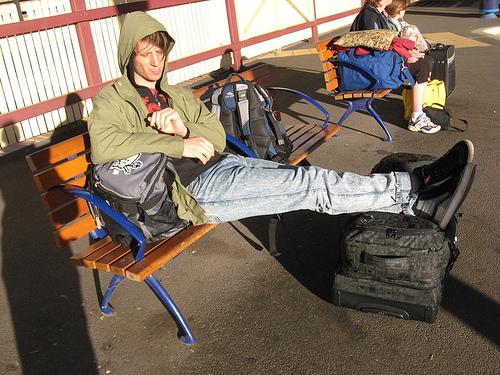Are these travelers waiting for a ride?
Quick response, please. Yes. What is the man sitting on?
Concise answer only. Bench. Is the man sleeping?
Concise answer only. No. 